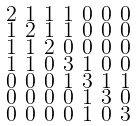<formula> <loc_0><loc_0><loc_500><loc_500>\begin{smallmatrix} 2 & 1 & 1 & 1 & 0 & 0 & 0 \\ 1 & 2 & 1 & 1 & 0 & 0 & 0 \\ 1 & 1 & 2 & 0 & 0 & 0 & 0 \\ 1 & 1 & 0 & 3 & 1 & 0 & 0 \\ 0 & 0 & 0 & 1 & 3 & 1 & 1 \\ 0 & 0 & 0 & 0 & 1 & 3 & 0 \\ 0 & 0 & 0 & 0 & 1 & 0 & 3 \end{smallmatrix}</formula> 